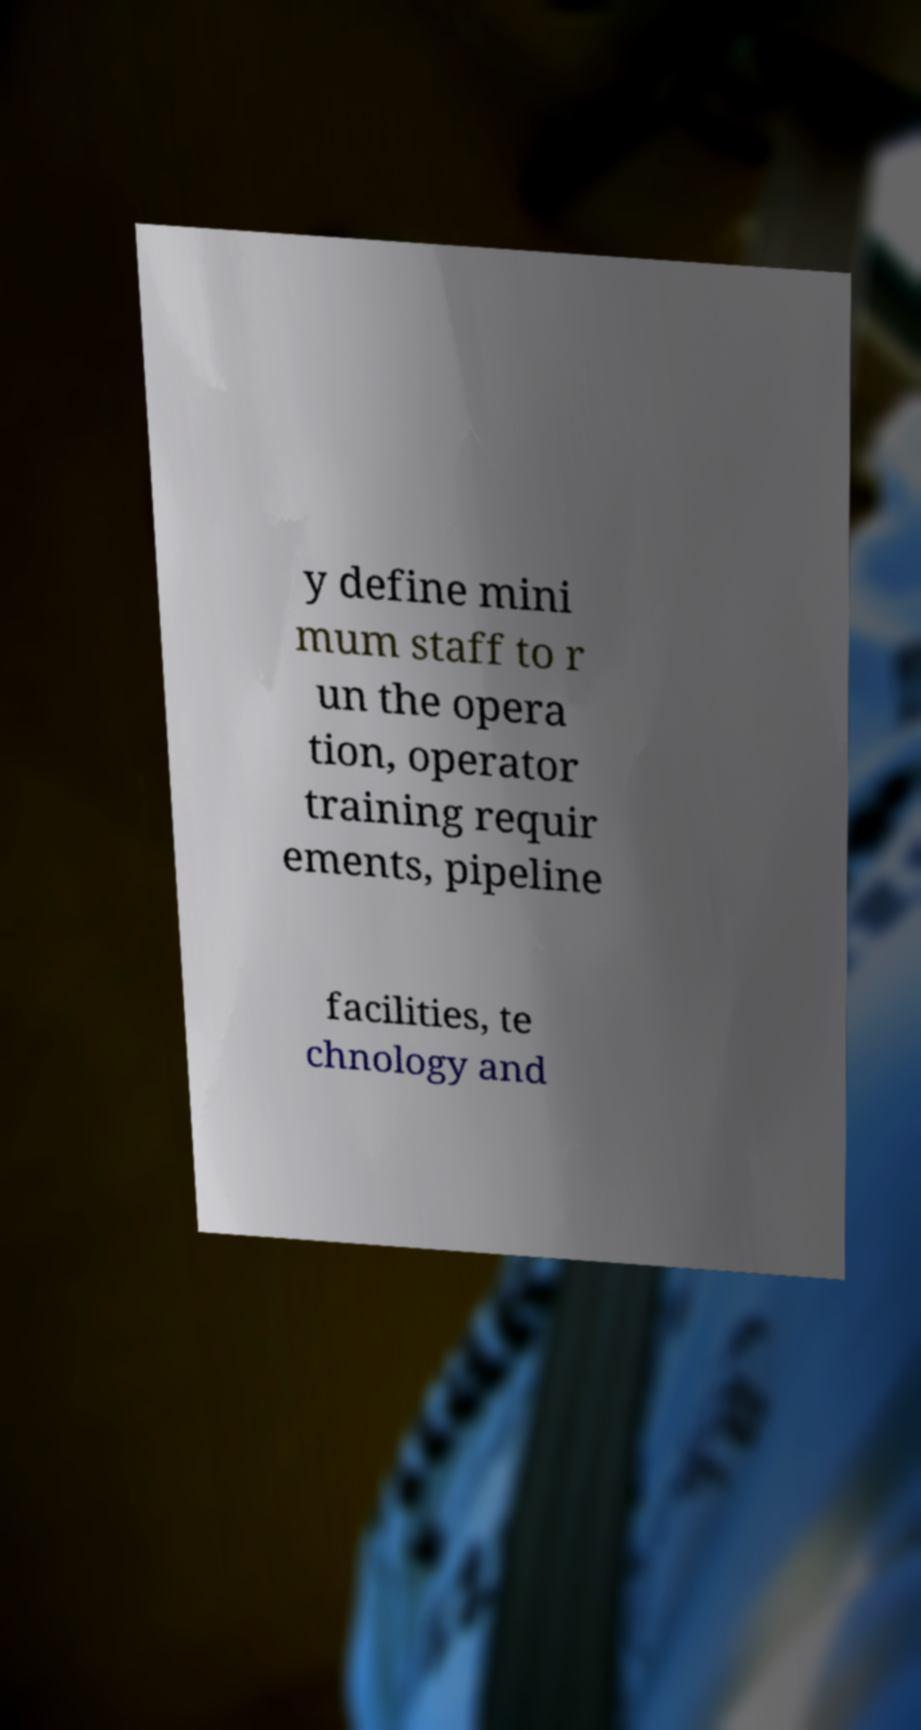Could you assist in decoding the text presented in this image and type it out clearly? y define mini mum staff to r un the opera tion, operator training requir ements, pipeline facilities, te chnology and 